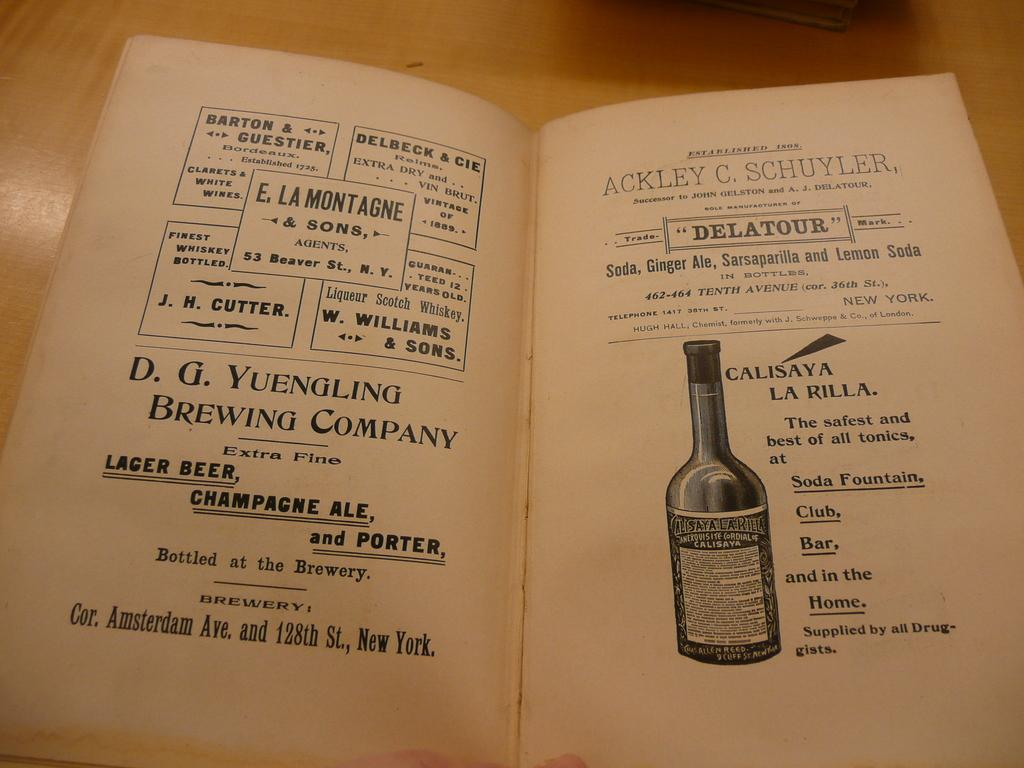<image>
Render a clear and concise summary of the photo. Two pages of advertisements featuring the D.G. Yuengling Brewing Company and Calisaya La Rilla. 